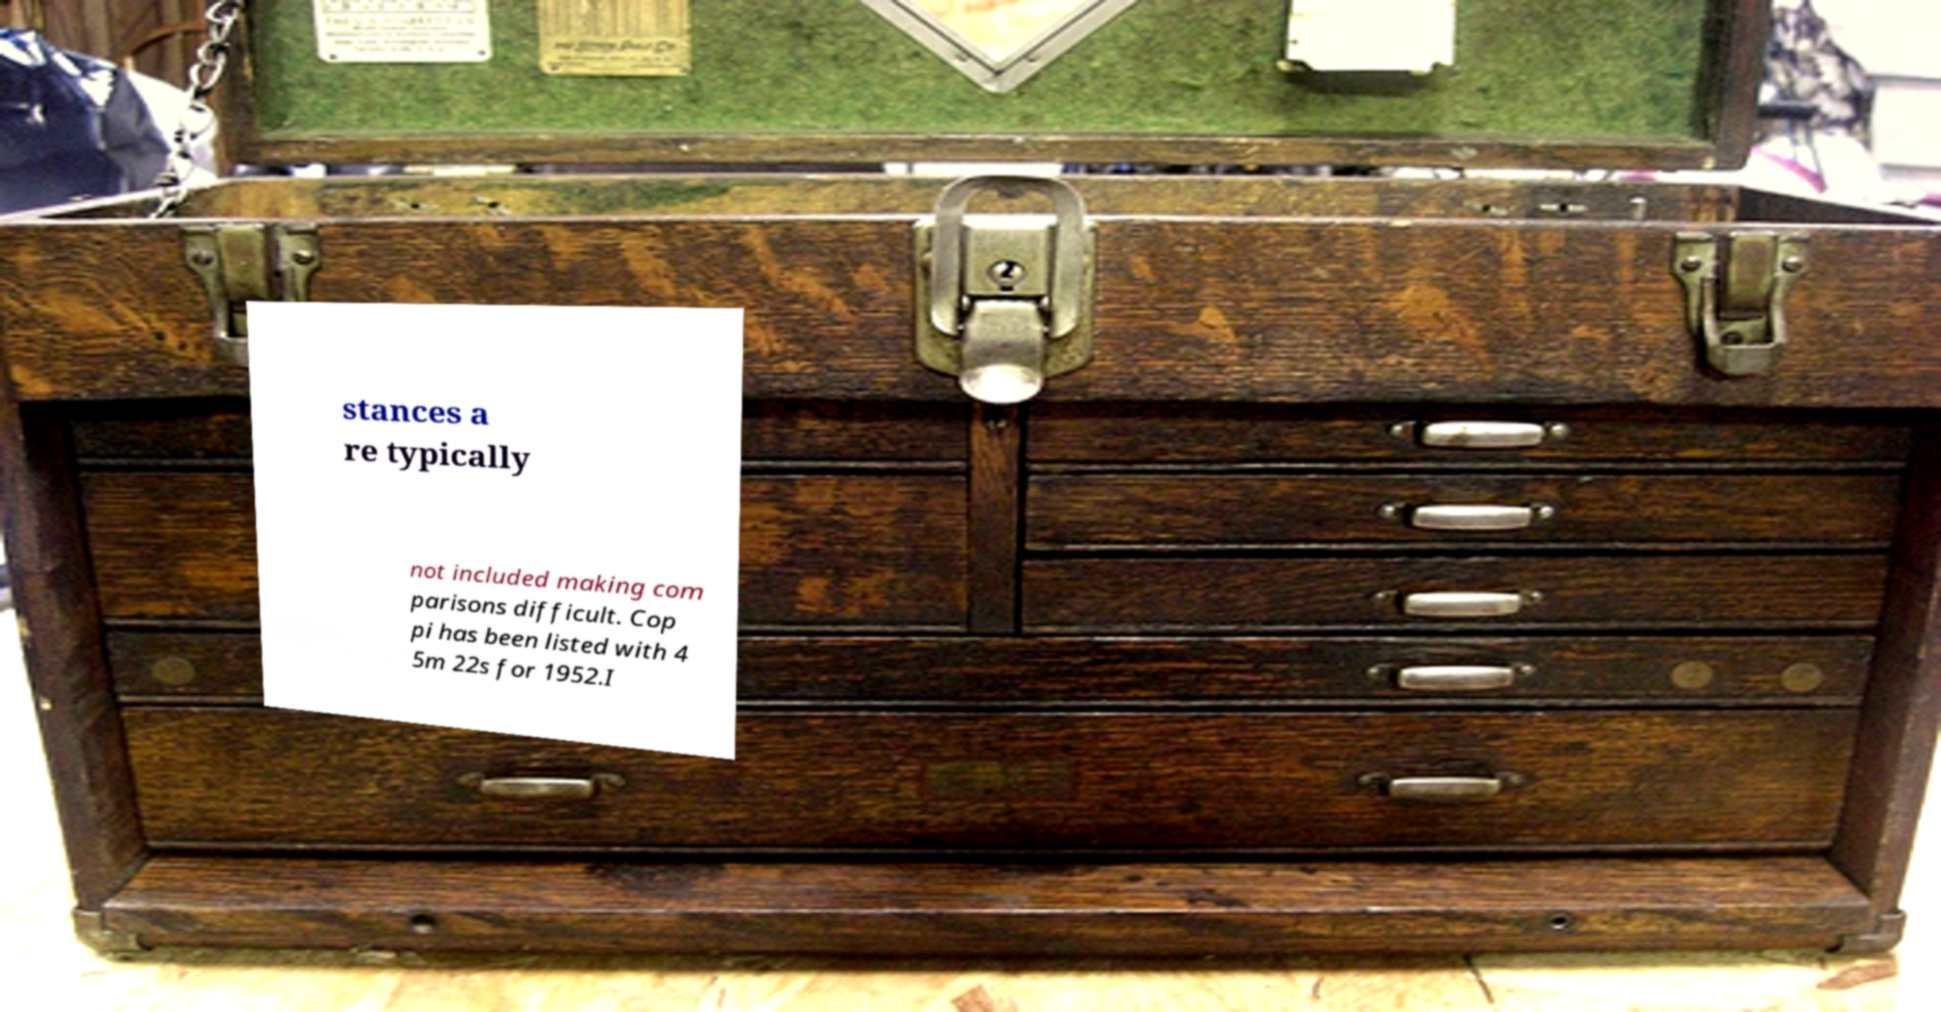I need the written content from this picture converted into text. Can you do that? stances a re typically not included making com parisons difficult. Cop pi has been listed with 4 5m 22s for 1952.I 